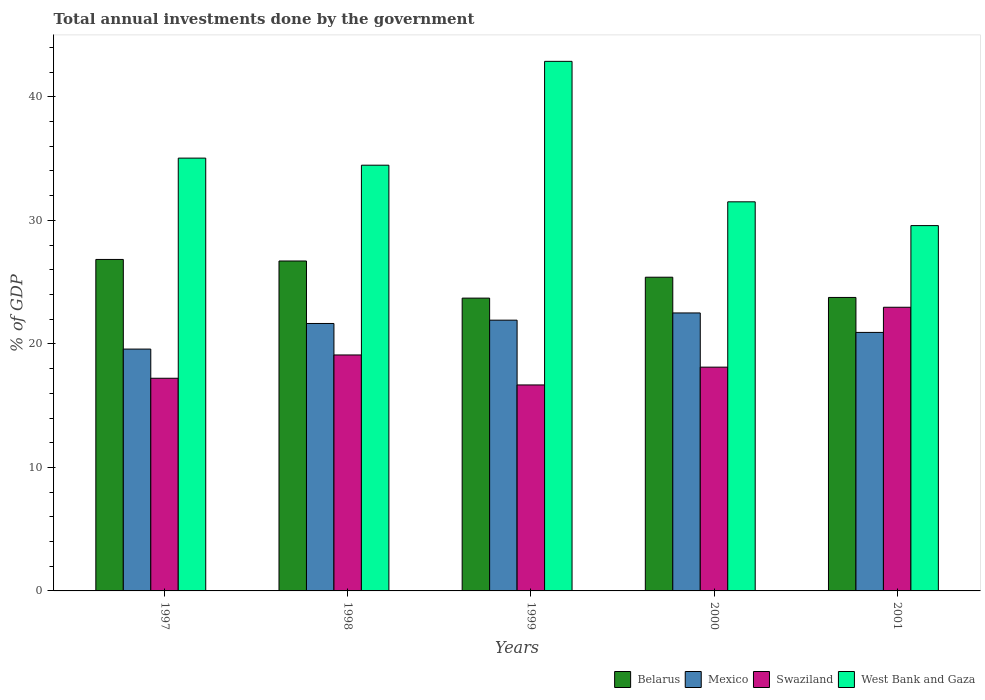How many different coloured bars are there?
Provide a short and direct response. 4. How many groups of bars are there?
Your answer should be very brief. 5. Are the number of bars per tick equal to the number of legend labels?
Offer a terse response. Yes. How many bars are there on the 1st tick from the left?
Make the answer very short. 4. What is the label of the 1st group of bars from the left?
Provide a short and direct response. 1997. In how many cases, is the number of bars for a given year not equal to the number of legend labels?
Provide a short and direct response. 0. What is the total annual investments done by the government in Belarus in 2001?
Offer a very short reply. 23.76. Across all years, what is the maximum total annual investments done by the government in Belarus?
Offer a terse response. 26.84. Across all years, what is the minimum total annual investments done by the government in Belarus?
Provide a short and direct response. 23.71. In which year was the total annual investments done by the government in Belarus maximum?
Offer a terse response. 1997. What is the total total annual investments done by the government in Belarus in the graph?
Offer a terse response. 126.42. What is the difference between the total annual investments done by the government in Mexico in 1997 and that in 2001?
Your answer should be very brief. -1.35. What is the difference between the total annual investments done by the government in Swaziland in 1998 and the total annual investments done by the government in Mexico in 1999?
Ensure brevity in your answer.  -2.82. What is the average total annual investments done by the government in Mexico per year?
Keep it short and to the point. 21.32. In the year 2000, what is the difference between the total annual investments done by the government in Swaziland and total annual investments done by the government in Belarus?
Your answer should be compact. -7.28. What is the ratio of the total annual investments done by the government in Belarus in 1999 to that in 2000?
Give a very brief answer. 0.93. Is the total annual investments done by the government in Mexico in 1999 less than that in 2001?
Offer a terse response. No. What is the difference between the highest and the second highest total annual investments done by the government in West Bank and Gaza?
Give a very brief answer. 7.83. What is the difference between the highest and the lowest total annual investments done by the government in West Bank and Gaza?
Offer a very short reply. 13.3. Is the sum of the total annual investments done by the government in Swaziland in 1997 and 2001 greater than the maximum total annual investments done by the government in Belarus across all years?
Provide a succinct answer. Yes. What does the 4th bar from the left in 1999 represents?
Offer a terse response. West Bank and Gaza. What does the 1st bar from the right in 1997 represents?
Keep it short and to the point. West Bank and Gaza. Are all the bars in the graph horizontal?
Keep it short and to the point. No. Are the values on the major ticks of Y-axis written in scientific E-notation?
Keep it short and to the point. No. Does the graph contain grids?
Keep it short and to the point. No. How are the legend labels stacked?
Ensure brevity in your answer.  Horizontal. What is the title of the graph?
Provide a succinct answer. Total annual investments done by the government. Does "Small states" appear as one of the legend labels in the graph?
Provide a succinct answer. No. What is the label or title of the X-axis?
Offer a very short reply. Years. What is the label or title of the Y-axis?
Your response must be concise. % of GDP. What is the % of GDP in Belarus in 1997?
Your answer should be compact. 26.84. What is the % of GDP of Mexico in 1997?
Your answer should be compact. 19.58. What is the % of GDP of Swaziland in 1997?
Your answer should be compact. 17.22. What is the % of GDP of West Bank and Gaza in 1997?
Provide a short and direct response. 35.04. What is the % of GDP of Belarus in 1998?
Provide a succinct answer. 26.71. What is the % of GDP in Mexico in 1998?
Give a very brief answer. 21.65. What is the % of GDP in Swaziland in 1998?
Provide a succinct answer. 19.1. What is the % of GDP in West Bank and Gaza in 1998?
Provide a succinct answer. 34.47. What is the % of GDP of Belarus in 1999?
Your answer should be very brief. 23.71. What is the % of GDP in Mexico in 1999?
Make the answer very short. 21.92. What is the % of GDP in Swaziland in 1999?
Your answer should be very brief. 16.68. What is the % of GDP in West Bank and Gaza in 1999?
Provide a succinct answer. 42.88. What is the % of GDP in Belarus in 2000?
Offer a terse response. 25.4. What is the % of GDP in Mexico in 2000?
Your answer should be compact. 22.51. What is the % of GDP in Swaziland in 2000?
Your answer should be very brief. 18.12. What is the % of GDP of West Bank and Gaza in 2000?
Provide a succinct answer. 31.5. What is the % of GDP in Belarus in 2001?
Provide a short and direct response. 23.76. What is the % of GDP of Mexico in 2001?
Provide a short and direct response. 20.93. What is the % of GDP of Swaziland in 2001?
Your answer should be compact. 22.97. What is the % of GDP of West Bank and Gaza in 2001?
Ensure brevity in your answer.  29.58. Across all years, what is the maximum % of GDP of Belarus?
Offer a very short reply. 26.84. Across all years, what is the maximum % of GDP in Mexico?
Offer a terse response. 22.51. Across all years, what is the maximum % of GDP in Swaziland?
Your answer should be very brief. 22.97. Across all years, what is the maximum % of GDP of West Bank and Gaza?
Your answer should be very brief. 42.88. Across all years, what is the minimum % of GDP of Belarus?
Provide a short and direct response. 23.71. Across all years, what is the minimum % of GDP in Mexico?
Offer a very short reply. 19.58. Across all years, what is the minimum % of GDP in Swaziland?
Offer a very short reply. 16.68. Across all years, what is the minimum % of GDP of West Bank and Gaza?
Give a very brief answer. 29.58. What is the total % of GDP in Belarus in the graph?
Provide a short and direct response. 126.42. What is the total % of GDP of Mexico in the graph?
Offer a very short reply. 106.59. What is the total % of GDP of Swaziland in the graph?
Make the answer very short. 94.08. What is the total % of GDP of West Bank and Gaza in the graph?
Your response must be concise. 173.47. What is the difference between the % of GDP in Belarus in 1997 and that in 1998?
Offer a very short reply. 0.12. What is the difference between the % of GDP in Mexico in 1997 and that in 1998?
Offer a terse response. -2.07. What is the difference between the % of GDP of Swaziland in 1997 and that in 1998?
Give a very brief answer. -1.89. What is the difference between the % of GDP in West Bank and Gaza in 1997 and that in 1998?
Keep it short and to the point. 0.57. What is the difference between the % of GDP of Belarus in 1997 and that in 1999?
Keep it short and to the point. 3.13. What is the difference between the % of GDP in Mexico in 1997 and that in 1999?
Provide a short and direct response. -2.34. What is the difference between the % of GDP of Swaziland in 1997 and that in 1999?
Your answer should be compact. 0.54. What is the difference between the % of GDP in West Bank and Gaza in 1997 and that in 1999?
Offer a very short reply. -7.83. What is the difference between the % of GDP in Belarus in 1997 and that in 2000?
Keep it short and to the point. 1.44. What is the difference between the % of GDP of Mexico in 1997 and that in 2000?
Provide a succinct answer. -2.93. What is the difference between the % of GDP of Swaziland in 1997 and that in 2000?
Keep it short and to the point. -0.9. What is the difference between the % of GDP of West Bank and Gaza in 1997 and that in 2000?
Your answer should be compact. 3.54. What is the difference between the % of GDP of Belarus in 1997 and that in 2001?
Make the answer very short. 3.08. What is the difference between the % of GDP of Mexico in 1997 and that in 2001?
Your answer should be compact. -1.35. What is the difference between the % of GDP of Swaziland in 1997 and that in 2001?
Provide a succinct answer. -5.75. What is the difference between the % of GDP of West Bank and Gaza in 1997 and that in 2001?
Make the answer very short. 5.46. What is the difference between the % of GDP of Belarus in 1998 and that in 1999?
Keep it short and to the point. 3.01. What is the difference between the % of GDP in Mexico in 1998 and that in 1999?
Your answer should be compact. -0.27. What is the difference between the % of GDP in Swaziland in 1998 and that in 1999?
Keep it short and to the point. 2.43. What is the difference between the % of GDP of West Bank and Gaza in 1998 and that in 1999?
Make the answer very short. -8.41. What is the difference between the % of GDP in Belarus in 1998 and that in 2000?
Provide a short and direct response. 1.31. What is the difference between the % of GDP of Mexico in 1998 and that in 2000?
Give a very brief answer. -0.85. What is the difference between the % of GDP of Swaziland in 1998 and that in 2000?
Provide a succinct answer. 0.99. What is the difference between the % of GDP in West Bank and Gaza in 1998 and that in 2000?
Your answer should be very brief. 2.97. What is the difference between the % of GDP of Belarus in 1998 and that in 2001?
Provide a succinct answer. 2.95. What is the difference between the % of GDP in Mexico in 1998 and that in 2001?
Your answer should be very brief. 0.72. What is the difference between the % of GDP in Swaziland in 1998 and that in 2001?
Offer a very short reply. -3.86. What is the difference between the % of GDP in West Bank and Gaza in 1998 and that in 2001?
Your answer should be compact. 4.89. What is the difference between the % of GDP in Belarus in 1999 and that in 2000?
Your answer should be very brief. -1.69. What is the difference between the % of GDP in Mexico in 1999 and that in 2000?
Provide a short and direct response. -0.58. What is the difference between the % of GDP of Swaziland in 1999 and that in 2000?
Make the answer very short. -1.44. What is the difference between the % of GDP in West Bank and Gaza in 1999 and that in 2000?
Ensure brevity in your answer.  11.37. What is the difference between the % of GDP in Belarus in 1999 and that in 2001?
Provide a succinct answer. -0.05. What is the difference between the % of GDP in Mexico in 1999 and that in 2001?
Give a very brief answer. 0.99. What is the difference between the % of GDP in Swaziland in 1999 and that in 2001?
Your answer should be compact. -6.29. What is the difference between the % of GDP of West Bank and Gaza in 1999 and that in 2001?
Your answer should be compact. 13.3. What is the difference between the % of GDP in Belarus in 2000 and that in 2001?
Offer a very short reply. 1.64. What is the difference between the % of GDP in Mexico in 2000 and that in 2001?
Make the answer very short. 1.58. What is the difference between the % of GDP of Swaziland in 2000 and that in 2001?
Your answer should be very brief. -4.85. What is the difference between the % of GDP in West Bank and Gaza in 2000 and that in 2001?
Provide a short and direct response. 1.93. What is the difference between the % of GDP of Belarus in 1997 and the % of GDP of Mexico in 1998?
Make the answer very short. 5.18. What is the difference between the % of GDP in Belarus in 1997 and the % of GDP in Swaziland in 1998?
Give a very brief answer. 7.73. What is the difference between the % of GDP of Belarus in 1997 and the % of GDP of West Bank and Gaza in 1998?
Provide a succinct answer. -7.63. What is the difference between the % of GDP of Mexico in 1997 and the % of GDP of Swaziland in 1998?
Provide a succinct answer. 0.48. What is the difference between the % of GDP in Mexico in 1997 and the % of GDP in West Bank and Gaza in 1998?
Provide a succinct answer. -14.89. What is the difference between the % of GDP in Swaziland in 1997 and the % of GDP in West Bank and Gaza in 1998?
Your response must be concise. -17.25. What is the difference between the % of GDP of Belarus in 1997 and the % of GDP of Mexico in 1999?
Your response must be concise. 4.92. What is the difference between the % of GDP in Belarus in 1997 and the % of GDP in Swaziland in 1999?
Provide a succinct answer. 10.16. What is the difference between the % of GDP of Belarus in 1997 and the % of GDP of West Bank and Gaza in 1999?
Give a very brief answer. -16.04. What is the difference between the % of GDP of Mexico in 1997 and the % of GDP of Swaziland in 1999?
Give a very brief answer. 2.9. What is the difference between the % of GDP of Mexico in 1997 and the % of GDP of West Bank and Gaza in 1999?
Keep it short and to the point. -23.3. What is the difference between the % of GDP in Swaziland in 1997 and the % of GDP in West Bank and Gaza in 1999?
Ensure brevity in your answer.  -25.66. What is the difference between the % of GDP of Belarus in 1997 and the % of GDP of Mexico in 2000?
Keep it short and to the point. 4.33. What is the difference between the % of GDP in Belarus in 1997 and the % of GDP in Swaziland in 2000?
Your response must be concise. 8.72. What is the difference between the % of GDP of Belarus in 1997 and the % of GDP of West Bank and Gaza in 2000?
Offer a very short reply. -4.67. What is the difference between the % of GDP of Mexico in 1997 and the % of GDP of Swaziland in 2000?
Your answer should be compact. 1.46. What is the difference between the % of GDP in Mexico in 1997 and the % of GDP in West Bank and Gaza in 2000?
Ensure brevity in your answer.  -11.92. What is the difference between the % of GDP in Swaziland in 1997 and the % of GDP in West Bank and Gaza in 2000?
Your response must be concise. -14.29. What is the difference between the % of GDP in Belarus in 1997 and the % of GDP in Mexico in 2001?
Your answer should be very brief. 5.91. What is the difference between the % of GDP in Belarus in 1997 and the % of GDP in Swaziland in 2001?
Offer a terse response. 3.87. What is the difference between the % of GDP of Belarus in 1997 and the % of GDP of West Bank and Gaza in 2001?
Offer a terse response. -2.74. What is the difference between the % of GDP in Mexico in 1997 and the % of GDP in Swaziland in 2001?
Provide a short and direct response. -3.39. What is the difference between the % of GDP in Mexico in 1997 and the % of GDP in West Bank and Gaza in 2001?
Offer a terse response. -10. What is the difference between the % of GDP in Swaziland in 1997 and the % of GDP in West Bank and Gaza in 2001?
Make the answer very short. -12.36. What is the difference between the % of GDP of Belarus in 1998 and the % of GDP of Mexico in 1999?
Make the answer very short. 4.79. What is the difference between the % of GDP in Belarus in 1998 and the % of GDP in Swaziland in 1999?
Ensure brevity in your answer.  10.04. What is the difference between the % of GDP in Belarus in 1998 and the % of GDP in West Bank and Gaza in 1999?
Your response must be concise. -16.16. What is the difference between the % of GDP in Mexico in 1998 and the % of GDP in Swaziland in 1999?
Your response must be concise. 4.98. What is the difference between the % of GDP of Mexico in 1998 and the % of GDP of West Bank and Gaza in 1999?
Keep it short and to the point. -21.22. What is the difference between the % of GDP of Swaziland in 1998 and the % of GDP of West Bank and Gaza in 1999?
Your answer should be compact. -23.77. What is the difference between the % of GDP in Belarus in 1998 and the % of GDP in Mexico in 2000?
Your response must be concise. 4.21. What is the difference between the % of GDP of Belarus in 1998 and the % of GDP of Swaziland in 2000?
Your answer should be very brief. 8.6. What is the difference between the % of GDP in Belarus in 1998 and the % of GDP in West Bank and Gaza in 2000?
Keep it short and to the point. -4.79. What is the difference between the % of GDP of Mexico in 1998 and the % of GDP of Swaziland in 2000?
Provide a succinct answer. 3.54. What is the difference between the % of GDP in Mexico in 1998 and the % of GDP in West Bank and Gaza in 2000?
Keep it short and to the point. -9.85. What is the difference between the % of GDP in Swaziland in 1998 and the % of GDP in West Bank and Gaza in 2000?
Make the answer very short. -12.4. What is the difference between the % of GDP in Belarus in 1998 and the % of GDP in Mexico in 2001?
Give a very brief answer. 5.78. What is the difference between the % of GDP of Belarus in 1998 and the % of GDP of Swaziland in 2001?
Provide a short and direct response. 3.75. What is the difference between the % of GDP in Belarus in 1998 and the % of GDP in West Bank and Gaza in 2001?
Offer a terse response. -2.87. What is the difference between the % of GDP in Mexico in 1998 and the % of GDP in Swaziland in 2001?
Offer a very short reply. -1.31. What is the difference between the % of GDP of Mexico in 1998 and the % of GDP of West Bank and Gaza in 2001?
Make the answer very short. -7.93. What is the difference between the % of GDP of Swaziland in 1998 and the % of GDP of West Bank and Gaza in 2001?
Provide a short and direct response. -10.47. What is the difference between the % of GDP of Belarus in 1999 and the % of GDP of Mexico in 2000?
Ensure brevity in your answer.  1.2. What is the difference between the % of GDP of Belarus in 1999 and the % of GDP of Swaziland in 2000?
Offer a terse response. 5.59. What is the difference between the % of GDP in Belarus in 1999 and the % of GDP in West Bank and Gaza in 2000?
Your answer should be very brief. -7.8. What is the difference between the % of GDP of Mexico in 1999 and the % of GDP of Swaziland in 2000?
Ensure brevity in your answer.  3.81. What is the difference between the % of GDP of Mexico in 1999 and the % of GDP of West Bank and Gaza in 2000?
Your response must be concise. -9.58. What is the difference between the % of GDP in Swaziland in 1999 and the % of GDP in West Bank and Gaza in 2000?
Provide a succinct answer. -14.83. What is the difference between the % of GDP in Belarus in 1999 and the % of GDP in Mexico in 2001?
Give a very brief answer. 2.78. What is the difference between the % of GDP of Belarus in 1999 and the % of GDP of Swaziland in 2001?
Your response must be concise. 0.74. What is the difference between the % of GDP in Belarus in 1999 and the % of GDP in West Bank and Gaza in 2001?
Provide a short and direct response. -5.87. What is the difference between the % of GDP of Mexico in 1999 and the % of GDP of Swaziland in 2001?
Your answer should be very brief. -1.04. What is the difference between the % of GDP in Mexico in 1999 and the % of GDP in West Bank and Gaza in 2001?
Offer a very short reply. -7.66. What is the difference between the % of GDP in Swaziland in 1999 and the % of GDP in West Bank and Gaza in 2001?
Make the answer very short. -12.9. What is the difference between the % of GDP in Belarus in 2000 and the % of GDP in Mexico in 2001?
Provide a succinct answer. 4.47. What is the difference between the % of GDP of Belarus in 2000 and the % of GDP of Swaziland in 2001?
Ensure brevity in your answer.  2.43. What is the difference between the % of GDP in Belarus in 2000 and the % of GDP in West Bank and Gaza in 2001?
Make the answer very short. -4.18. What is the difference between the % of GDP of Mexico in 2000 and the % of GDP of Swaziland in 2001?
Make the answer very short. -0.46. What is the difference between the % of GDP in Mexico in 2000 and the % of GDP in West Bank and Gaza in 2001?
Your answer should be compact. -7.07. What is the difference between the % of GDP in Swaziland in 2000 and the % of GDP in West Bank and Gaza in 2001?
Offer a very short reply. -11.46. What is the average % of GDP of Belarus per year?
Provide a succinct answer. 25.28. What is the average % of GDP of Mexico per year?
Offer a very short reply. 21.32. What is the average % of GDP of Swaziland per year?
Your response must be concise. 18.82. What is the average % of GDP in West Bank and Gaza per year?
Provide a succinct answer. 34.69. In the year 1997, what is the difference between the % of GDP of Belarus and % of GDP of Mexico?
Your answer should be very brief. 7.26. In the year 1997, what is the difference between the % of GDP in Belarus and % of GDP in Swaziland?
Ensure brevity in your answer.  9.62. In the year 1997, what is the difference between the % of GDP in Belarus and % of GDP in West Bank and Gaza?
Keep it short and to the point. -8.2. In the year 1997, what is the difference between the % of GDP in Mexico and % of GDP in Swaziland?
Offer a terse response. 2.36. In the year 1997, what is the difference between the % of GDP of Mexico and % of GDP of West Bank and Gaza?
Your response must be concise. -15.46. In the year 1997, what is the difference between the % of GDP of Swaziland and % of GDP of West Bank and Gaza?
Your answer should be compact. -17.82. In the year 1998, what is the difference between the % of GDP of Belarus and % of GDP of Mexico?
Your answer should be very brief. 5.06. In the year 1998, what is the difference between the % of GDP in Belarus and % of GDP in Swaziland?
Your answer should be very brief. 7.61. In the year 1998, what is the difference between the % of GDP in Belarus and % of GDP in West Bank and Gaza?
Your response must be concise. -7.76. In the year 1998, what is the difference between the % of GDP of Mexico and % of GDP of Swaziland?
Ensure brevity in your answer.  2.55. In the year 1998, what is the difference between the % of GDP of Mexico and % of GDP of West Bank and Gaza?
Keep it short and to the point. -12.82. In the year 1998, what is the difference between the % of GDP in Swaziland and % of GDP in West Bank and Gaza?
Keep it short and to the point. -15.36. In the year 1999, what is the difference between the % of GDP in Belarus and % of GDP in Mexico?
Provide a short and direct response. 1.78. In the year 1999, what is the difference between the % of GDP of Belarus and % of GDP of Swaziland?
Ensure brevity in your answer.  7.03. In the year 1999, what is the difference between the % of GDP of Belarus and % of GDP of West Bank and Gaza?
Provide a succinct answer. -19.17. In the year 1999, what is the difference between the % of GDP in Mexico and % of GDP in Swaziland?
Keep it short and to the point. 5.25. In the year 1999, what is the difference between the % of GDP of Mexico and % of GDP of West Bank and Gaza?
Your answer should be compact. -20.95. In the year 1999, what is the difference between the % of GDP in Swaziland and % of GDP in West Bank and Gaza?
Offer a very short reply. -26.2. In the year 2000, what is the difference between the % of GDP in Belarus and % of GDP in Mexico?
Provide a succinct answer. 2.89. In the year 2000, what is the difference between the % of GDP in Belarus and % of GDP in Swaziland?
Give a very brief answer. 7.28. In the year 2000, what is the difference between the % of GDP of Belarus and % of GDP of West Bank and Gaza?
Ensure brevity in your answer.  -6.1. In the year 2000, what is the difference between the % of GDP of Mexico and % of GDP of Swaziland?
Provide a short and direct response. 4.39. In the year 2000, what is the difference between the % of GDP of Mexico and % of GDP of West Bank and Gaza?
Your answer should be compact. -9. In the year 2000, what is the difference between the % of GDP of Swaziland and % of GDP of West Bank and Gaza?
Keep it short and to the point. -13.39. In the year 2001, what is the difference between the % of GDP in Belarus and % of GDP in Mexico?
Provide a short and direct response. 2.83. In the year 2001, what is the difference between the % of GDP in Belarus and % of GDP in Swaziland?
Offer a very short reply. 0.79. In the year 2001, what is the difference between the % of GDP of Belarus and % of GDP of West Bank and Gaza?
Provide a short and direct response. -5.82. In the year 2001, what is the difference between the % of GDP in Mexico and % of GDP in Swaziland?
Your answer should be very brief. -2.04. In the year 2001, what is the difference between the % of GDP in Mexico and % of GDP in West Bank and Gaza?
Offer a terse response. -8.65. In the year 2001, what is the difference between the % of GDP of Swaziland and % of GDP of West Bank and Gaza?
Offer a very short reply. -6.61. What is the ratio of the % of GDP in Belarus in 1997 to that in 1998?
Your answer should be compact. 1. What is the ratio of the % of GDP in Mexico in 1997 to that in 1998?
Your response must be concise. 0.9. What is the ratio of the % of GDP in Swaziland in 1997 to that in 1998?
Keep it short and to the point. 0.9. What is the ratio of the % of GDP in West Bank and Gaza in 1997 to that in 1998?
Keep it short and to the point. 1.02. What is the ratio of the % of GDP in Belarus in 1997 to that in 1999?
Provide a short and direct response. 1.13. What is the ratio of the % of GDP of Mexico in 1997 to that in 1999?
Your response must be concise. 0.89. What is the ratio of the % of GDP of Swaziland in 1997 to that in 1999?
Provide a short and direct response. 1.03. What is the ratio of the % of GDP in West Bank and Gaza in 1997 to that in 1999?
Your answer should be compact. 0.82. What is the ratio of the % of GDP in Belarus in 1997 to that in 2000?
Provide a short and direct response. 1.06. What is the ratio of the % of GDP in Mexico in 1997 to that in 2000?
Your answer should be very brief. 0.87. What is the ratio of the % of GDP of Swaziland in 1997 to that in 2000?
Offer a terse response. 0.95. What is the ratio of the % of GDP of West Bank and Gaza in 1997 to that in 2000?
Your response must be concise. 1.11. What is the ratio of the % of GDP of Belarus in 1997 to that in 2001?
Your answer should be compact. 1.13. What is the ratio of the % of GDP of Mexico in 1997 to that in 2001?
Your answer should be very brief. 0.94. What is the ratio of the % of GDP in Swaziland in 1997 to that in 2001?
Your response must be concise. 0.75. What is the ratio of the % of GDP of West Bank and Gaza in 1997 to that in 2001?
Provide a succinct answer. 1.18. What is the ratio of the % of GDP in Belarus in 1998 to that in 1999?
Ensure brevity in your answer.  1.13. What is the ratio of the % of GDP of Swaziland in 1998 to that in 1999?
Offer a very short reply. 1.15. What is the ratio of the % of GDP in West Bank and Gaza in 1998 to that in 1999?
Your answer should be compact. 0.8. What is the ratio of the % of GDP in Belarus in 1998 to that in 2000?
Give a very brief answer. 1.05. What is the ratio of the % of GDP of Mexico in 1998 to that in 2000?
Offer a terse response. 0.96. What is the ratio of the % of GDP in Swaziland in 1998 to that in 2000?
Give a very brief answer. 1.05. What is the ratio of the % of GDP in West Bank and Gaza in 1998 to that in 2000?
Ensure brevity in your answer.  1.09. What is the ratio of the % of GDP in Belarus in 1998 to that in 2001?
Offer a very short reply. 1.12. What is the ratio of the % of GDP in Mexico in 1998 to that in 2001?
Your response must be concise. 1.03. What is the ratio of the % of GDP in Swaziland in 1998 to that in 2001?
Keep it short and to the point. 0.83. What is the ratio of the % of GDP of West Bank and Gaza in 1998 to that in 2001?
Offer a terse response. 1.17. What is the ratio of the % of GDP of Belarus in 1999 to that in 2000?
Provide a short and direct response. 0.93. What is the ratio of the % of GDP in Mexico in 1999 to that in 2000?
Make the answer very short. 0.97. What is the ratio of the % of GDP of Swaziland in 1999 to that in 2000?
Your answer should be compact. 0.92. What is the ratio of the % of GDP of West Bank and Gaza in 1999 to that in 2000?
Ensure brevity in your answer.  1.36. What is the ratio of the % of GDP in Belarus in 1999 to that in 2001?
Your answer should be very brief. 1. What is the ratio of the % of GDP in Mexico in 1999 to that in 2001?
Make the answer very short. 1.05. What is the ratio of the % of GDP in Swaziland in 1999 to that in 2001?
Provide a succinct answer. 0.73. What is the ratio of the % of GDP of West Bank and Gaza in 1999 to that in 2001?
Ensure brevity in your answer.  1.45. What is the ratio of the % of GDP in Belarus in 2000 to that in 2001?
Offer a terse response. 1.07. What is the ratio of the % of GDP of Mexico in 2000 to that in 2001?
Provide a succinct answer. 1.08. What is the ratio of the % of GDP of Swaziland in 2000 to that in 2001?
Make the answer very short. 0.79. What is the ratio of the % of GDP in West Bank and Gaza in 2000 to that in 2001?
Give a very brief answer. 1.07. What is the difference between the highest and the second highest % of GDP of Belarus?
Make the answer very short. 0.12. What is the difference between the highest and the second highest % of GDP in Mexico?
Provide a succinct answer. 0.58. What is the difference between the highest and the second highest % of GDP of Swaziland?
Provide a succinct answer. 3.86. What is the difference between the highest and the second highest % of GDP in West Bank and Gaza?
Offer a terse response. 7.83. What is the difference between the highest and the lowest % of GDP of Belarus?
Give a very brief answer. 3.13. What is the difference between the highest and the lowest % of GDP in Mexico?
Make the answer very short. 2.93. What is the difference between the highest and the lowest % of GDP of Swaziland?
Provide a short and direct response. 6.29. What is the difference between the highest and the lowest % of GDP of West Bank and Gaza?
Your response must be concise. 13.3. 